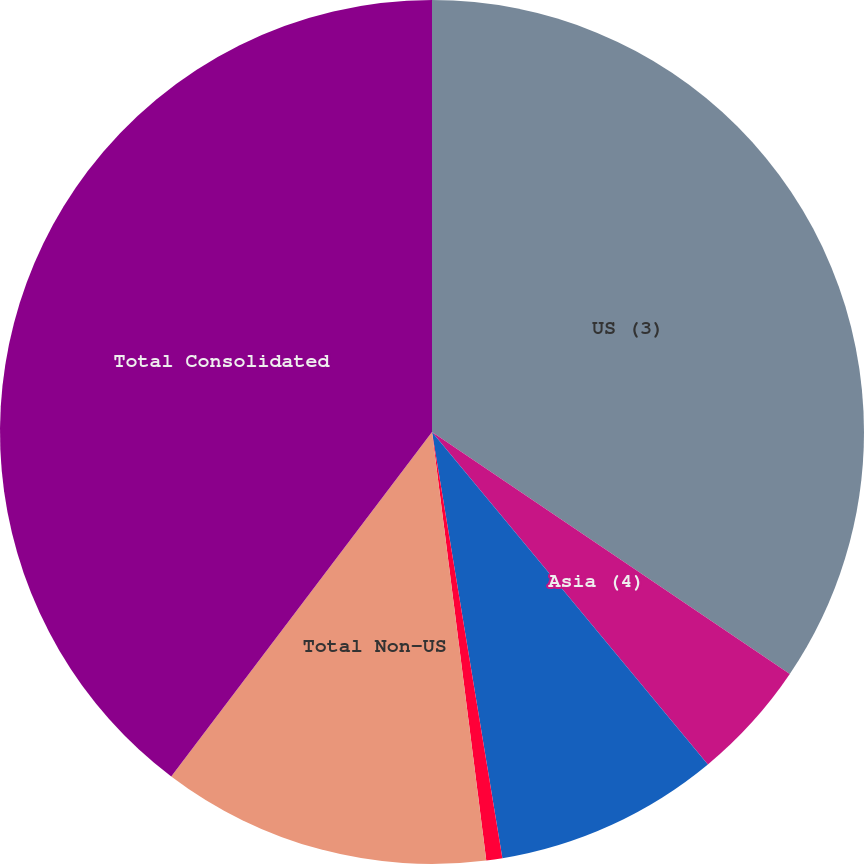<chart> <loc_0><loc_0><loc_500><loc_500><pie_chart><fcel>US (3)<fcel>Asia (4)<fcel>Europe Middle East and Africa<fcel>Latin America and the<fcel>Total Non-US<fcel>Total Consolidated<nl><fcel>34.47%<fcel>4.51%<fcel>8.42%<fcel>0.6%<fcel>12.32%<fcel>39.69%<nl></chart> 